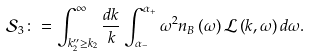<formula> <loc_0><loc_0><loc_500><loc_500>\mathcal { S } _ { 3 } \colon = \int _ { k _ { 2 } ^ { \prime \prime } \geq k _ { 2 } } ^ { \infty } \frac { d k } { k } \int _ { \alpha _ { - } } ^ { \alpha _ { + } } \omega ^ { 2 } n _ { B } \left ( \omega \right ) \mathcal { L } \left ( k , \omega \right ) d \omega .</formula> 